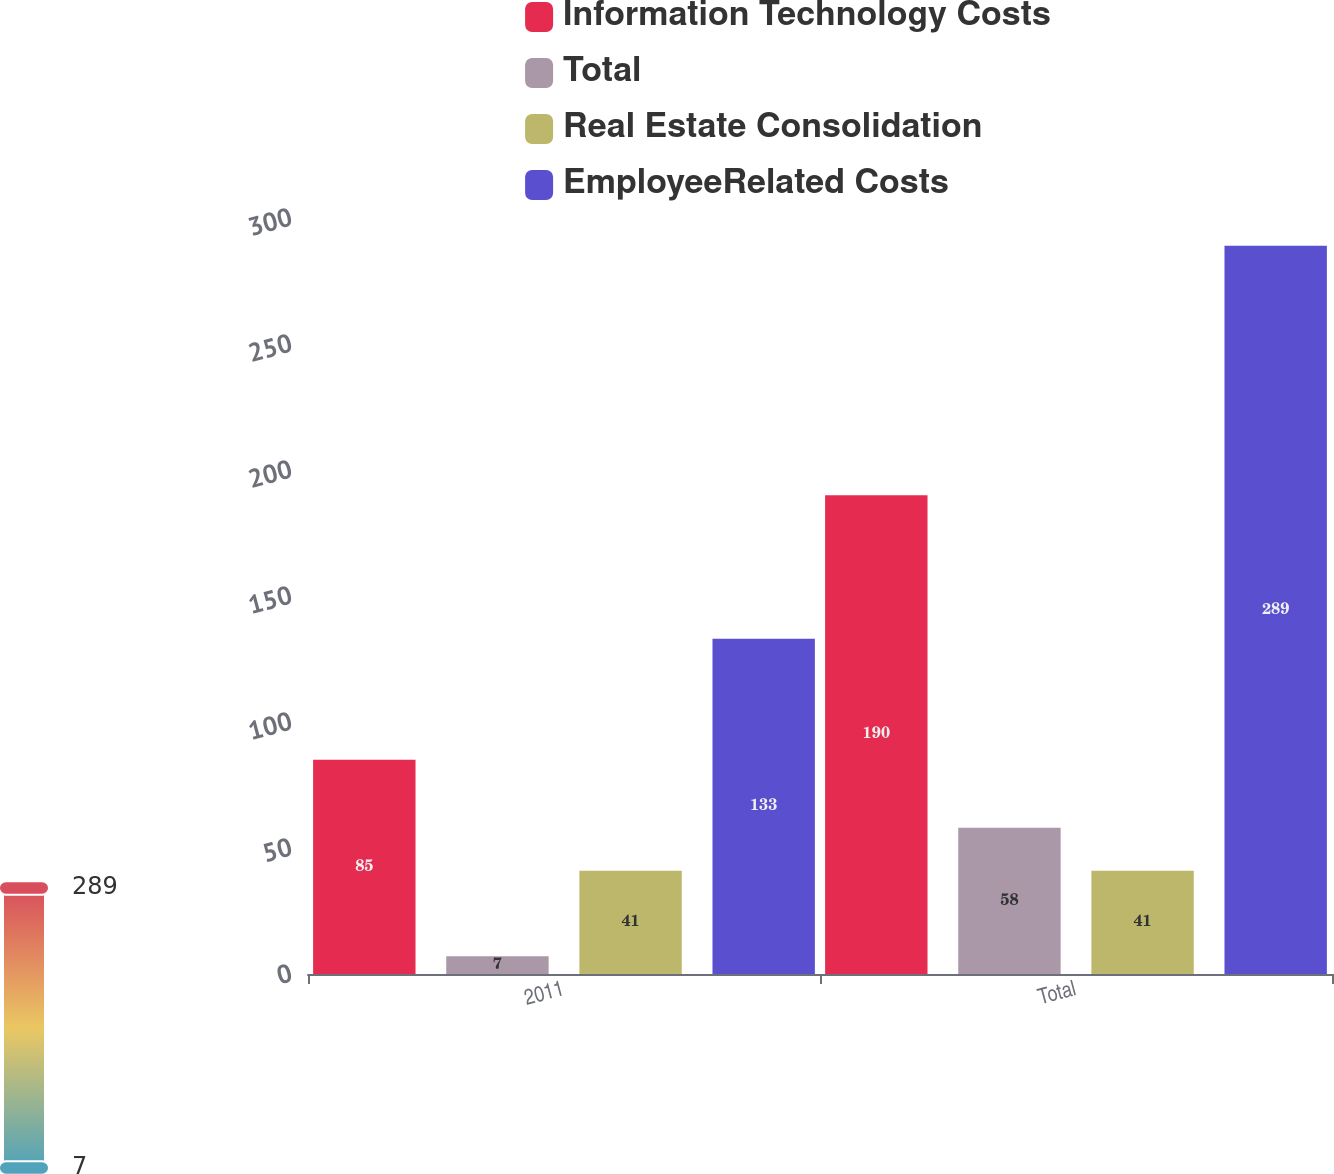Convert chart to OTSL. <chart><loc_0><loc_0><loc_500><loc_500><stacked_bar_chart><ecel><fcel>2011<fcel>Total<nl><fcel>Information Technology Costs<fcel>85<fcel>190<nl><fcel>Total<fcel>7<fcel>58<nl><fcel>Real Estate Consolidation<fcel>41<fcel>41<nl><fcel>EmployeeRelated Costs<fcel>133<fcel>289<nl></chart> 